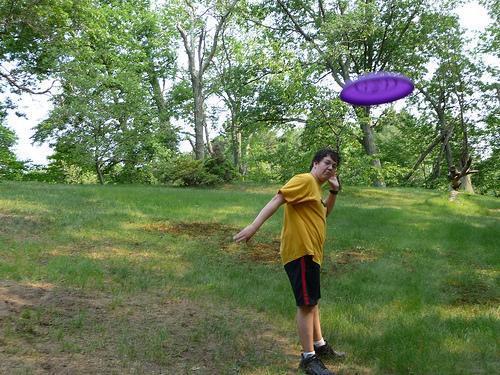How many people are there?
Give a very brief answer. 1. 